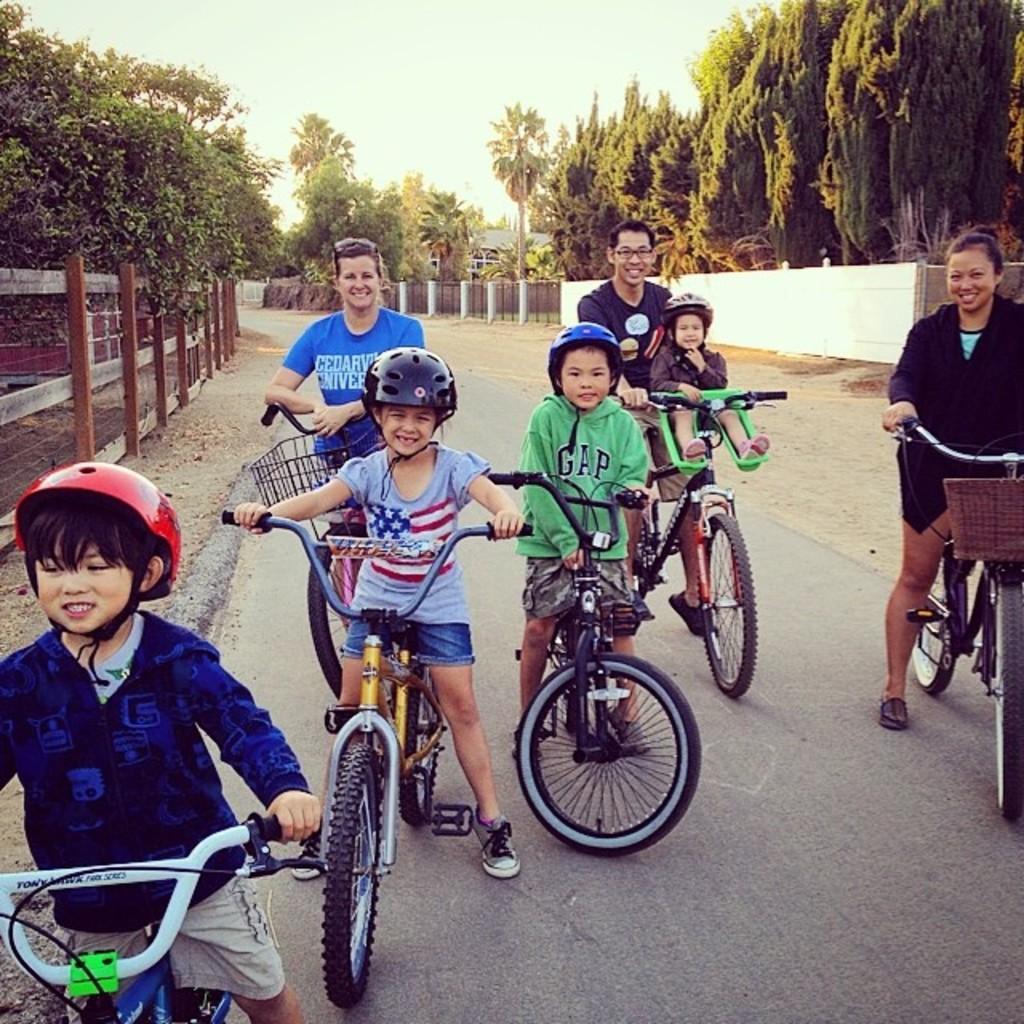Could you give a brief overview of what you see in this image? In this image there are group of people who are sitting on a cycle and on the background there are trees and sky is there. On the left side there is a fence and on the right side there is a wall. 